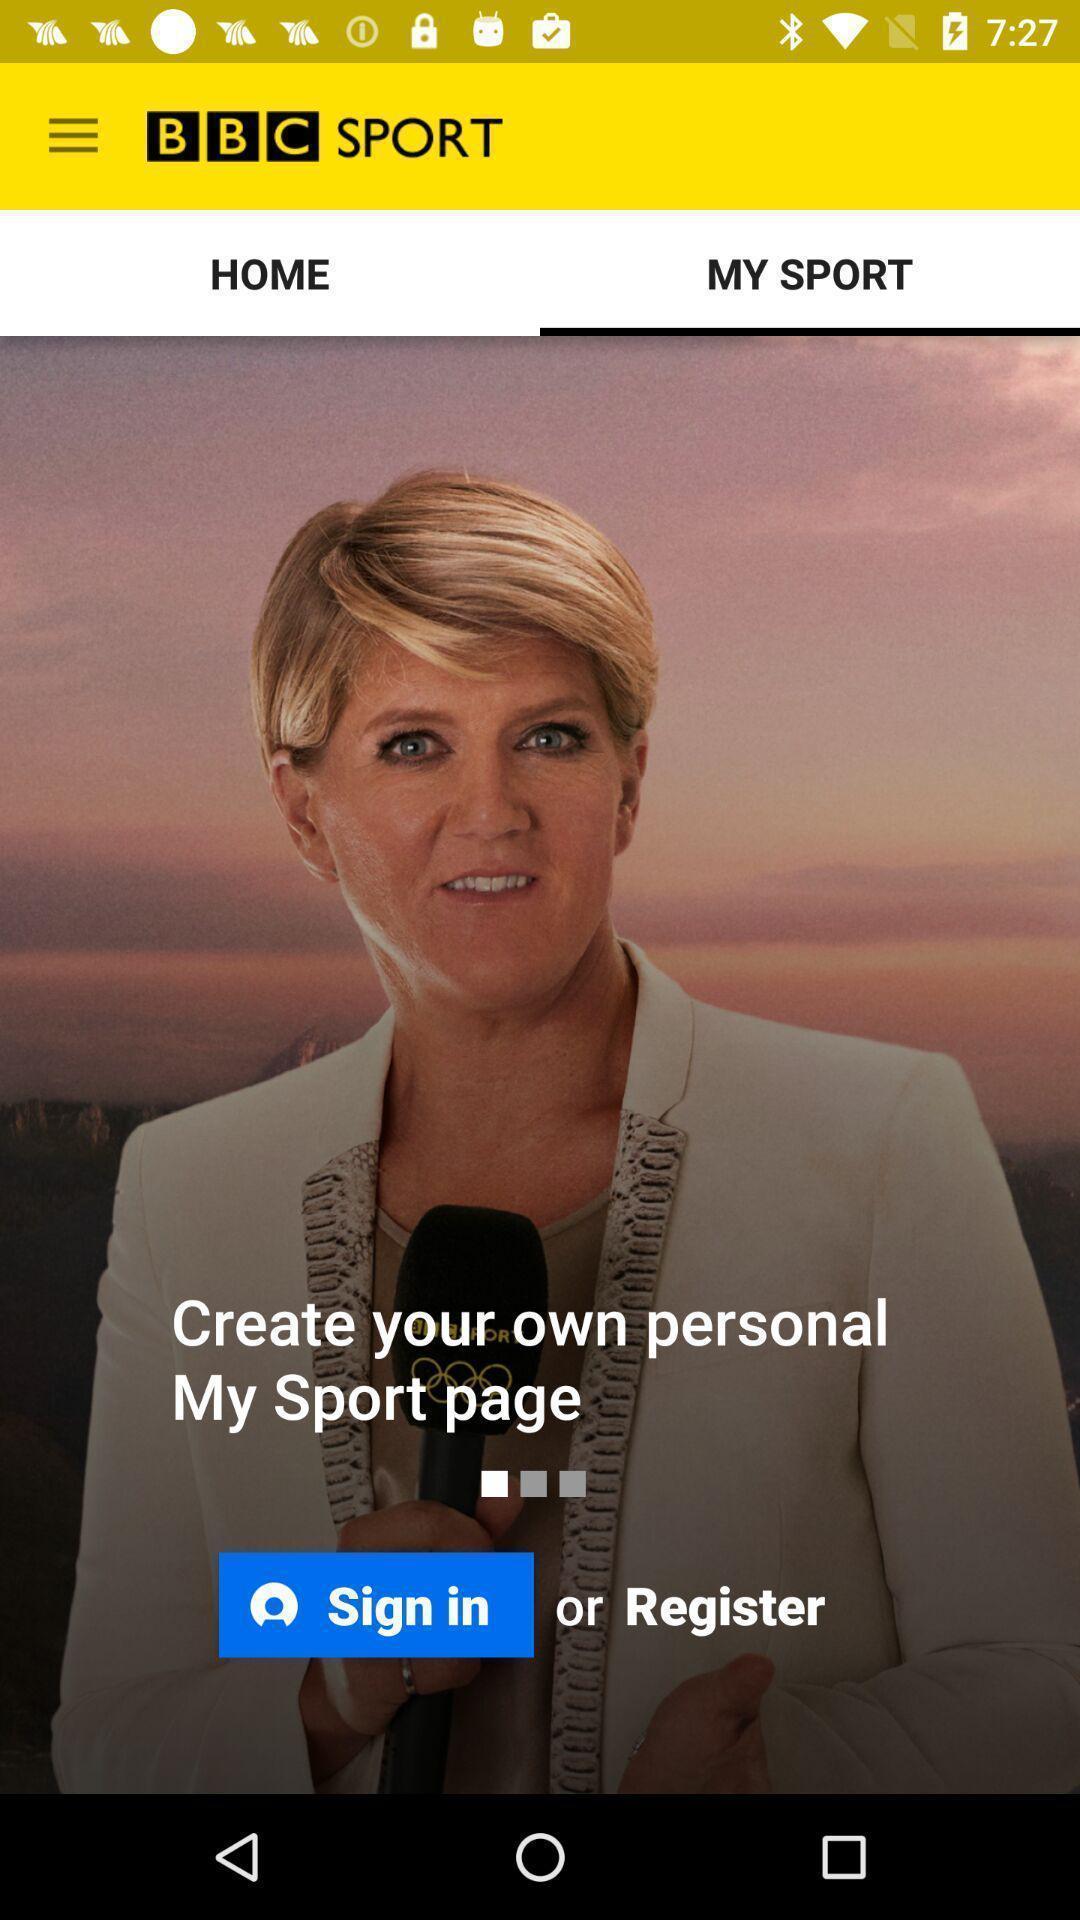What is the overall content of this screenshot? Sign in page. 